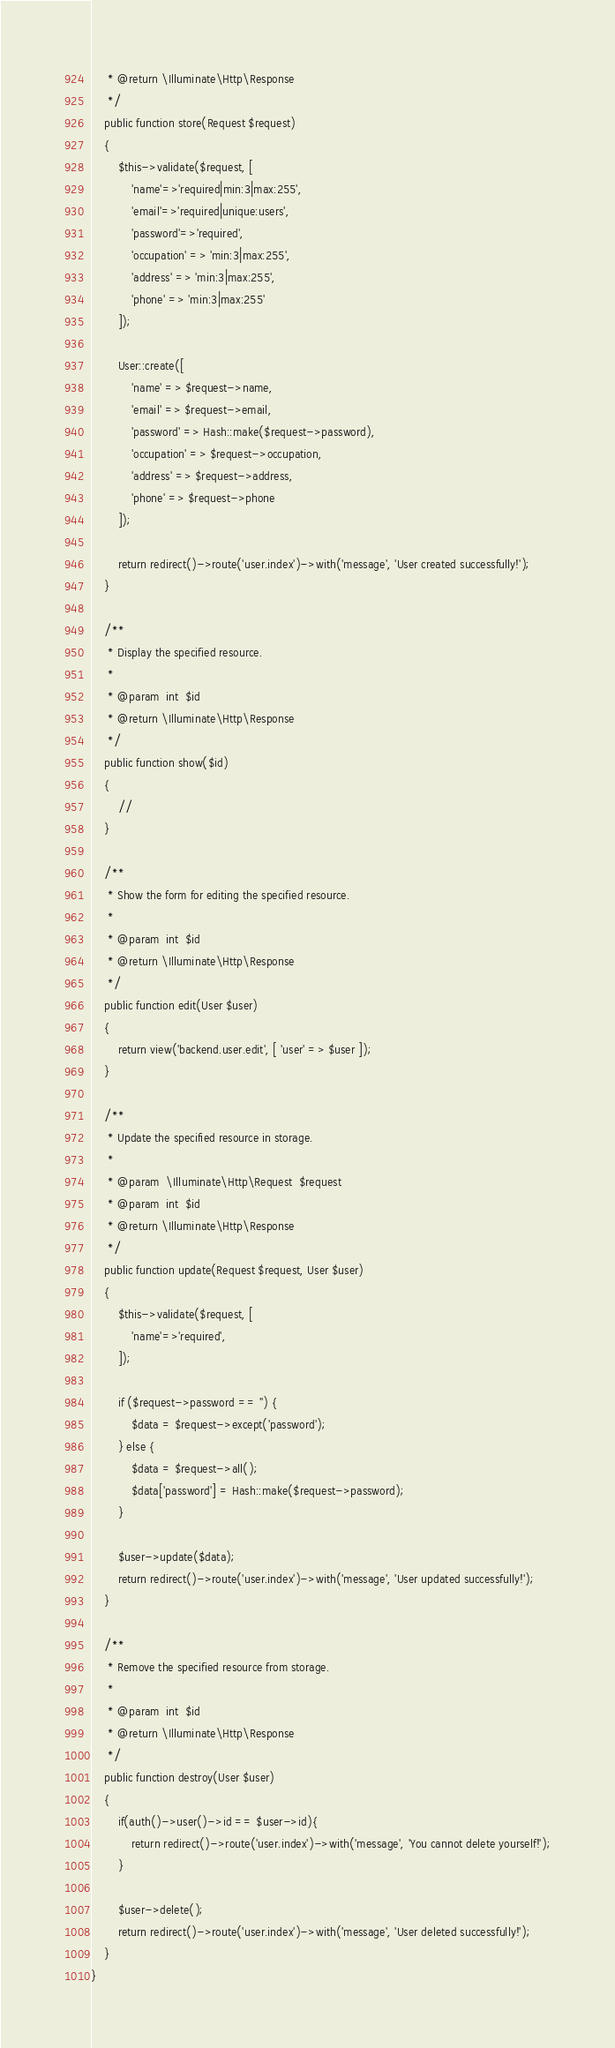Convert code to text. <code><loc_0><loc_0><loc_500><loc_500><_PHP_>     * @return \Illuminate\Http\Response
     */
    public function store(Request $request)
    {
        $this->validate($request, [
            'name'=>'required|min:3|max:255',
            'email'=>'required|unique:users',
            'password'=>'required',
            'occupation' => 'min:3|max:255',
            'address' => 'min:3|max:255',
            'phone' => 'min:3|max:255'
        ]);

        User::create([
            'name' => $request->name,
            'email' => $request->email,
            'password' => Hash::make($request->password),
            'occupation' => $request->occupation,
            'address' => $request->address,
            'phone' => $request->phone
        ]);

        return redirect()->route('user.index')->with('message', 'User created successfully!');
    }

    /**
     * Display the specified resource.
     *
     * @param  int  $id
     * @return \Illuminate\Http\Response
     */
    public function show($id)
    {
        //
    }

    /**
     * Show the form for editing the specified resource.
     *
     * @param  int  $id
     * @return \Illuminate\Http\Response
     */
    public function edit(User $user)
    {
        return view('backend.user.edit', [ 'user' => $user ]);
    }

    /**
     * Update the specified resource in storage.
     *
     * @param  \Illuminate\Http\Request  $request
     * @param  int  $id
     * @return \Illuminate\Http\Response
     */
    public function update(Request $request, User $user)
    {
        $this->validate($request, [
            'name'=>'required',
        ]);

        if ($request->password == '') {
            $data = $request->except('password');
        } else {
            $data = $request->all();
            $data['password'] = Hash::make($request->password);
        }

        $user->update($data);
        return redirect()->route('user.index')->with('message', 'User updated successfully!');
    }

    /**
     * Remove the specified resource from storage.
     *
     * @param  int  $id
     * @return \Illuminate\Http\Response
     */
    public function destroy(User $user)
    {
        if(auth()->user()->id == $user->id){
            return redirect()->route('user.index')->with('message', 'You cannot delete yourself!');
        }

        $user->delete();
        return redirect()->route('user.index')->with('message', 'User deleted successfully!');
    }
}
</code> 